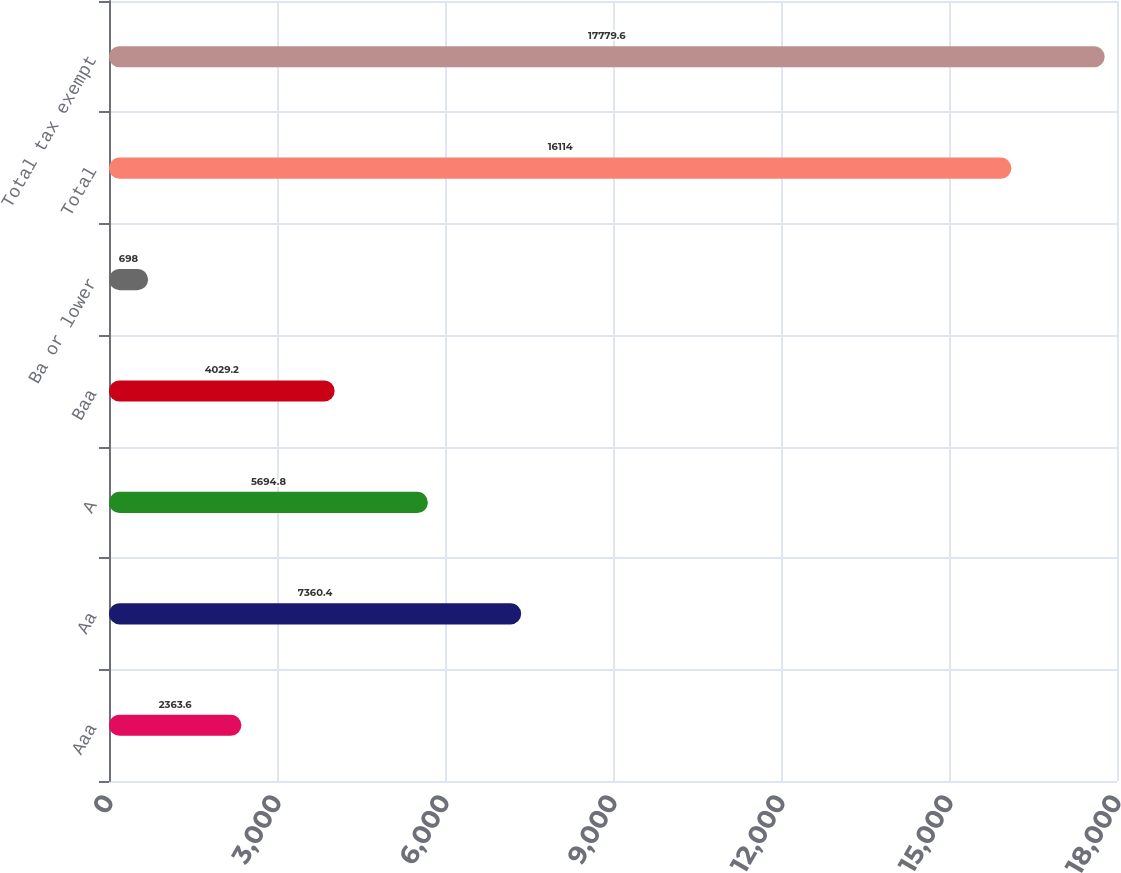<chart> <loc_0><loc_0><loc_500><loc_500><bar_chart><fcel>Aaa<fcel>Aa<fcel>A<fcel>Baa<fcel>Ba or lower<fcel>Total<fcel>Total tax exempt<nl><fcel>2363.6<fcel>7360.4<fcel>5694.8<fcel>4029.2<fcel>698<fcel>16114<fcel>17779.6<nl></chart> 